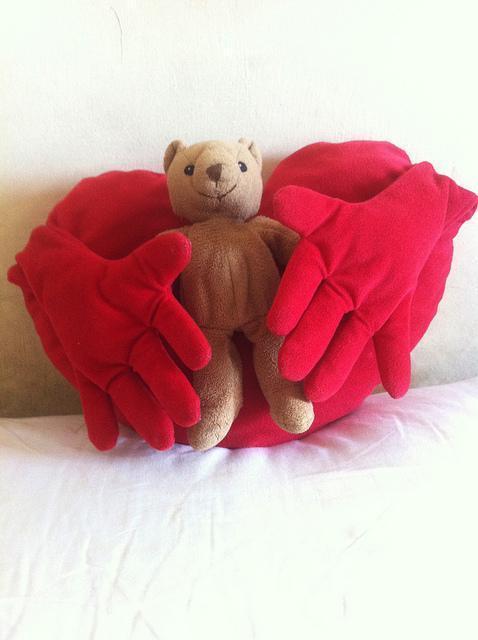How many fingers are on the heart's hand?
Give a very brief answer. 5. 